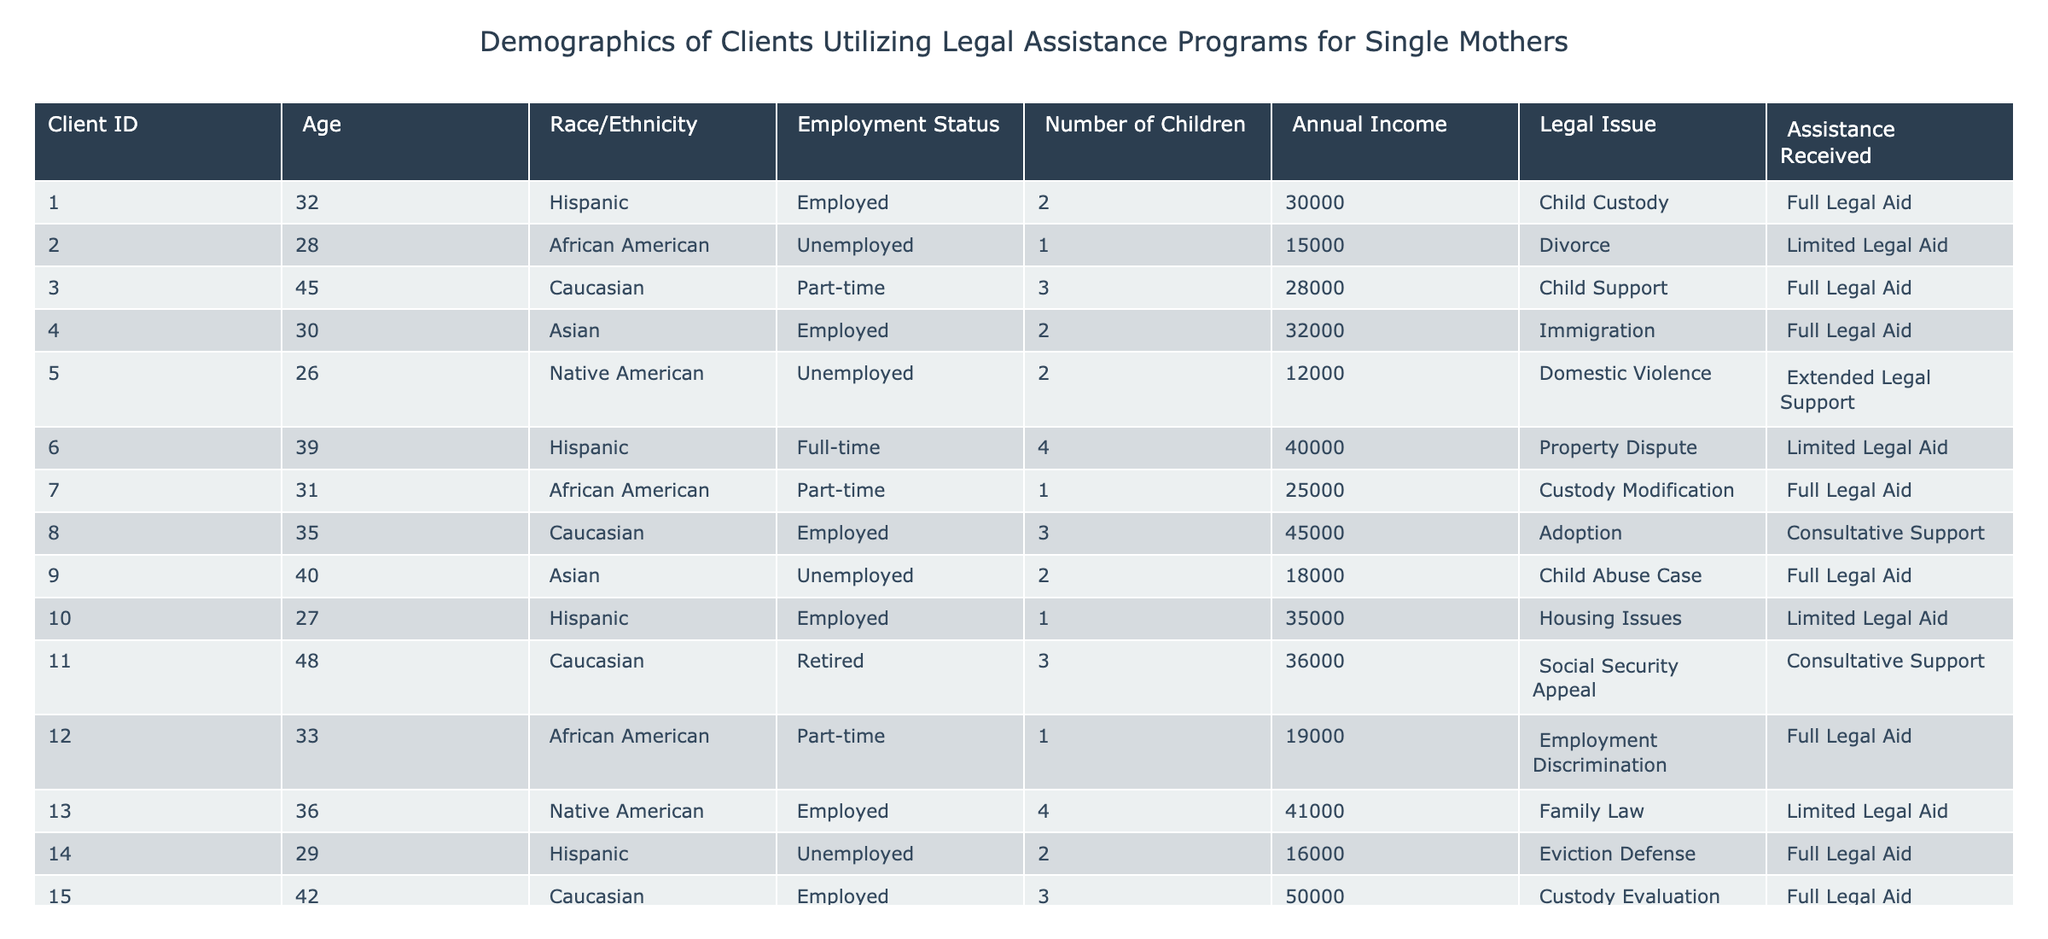What is the most common legal issue for clients in this table? By examining the "Legal Issue" column, we see that "Child Custody" appears 3 times (IDs 1, 7, and 14), which is more than any other legal issue.
Answer: Child Custody How many clients are unemployed? Looking at the "Employment Status" column, we see 5 entries marked as "Unemployed," specifically IDs 2, 5, 6, 9, and 14.
Answer: 5 What is the average number of children for clients receiving full legal aid? There are 8 clients who received full legal aid (IDs 1, 3, 4, 7, 9, 12, 14, 15) with a combined total of children equal to (2 + 3 + 2 + 1 + 2 + 1 + 2 + 3) = 16 children. Dividing by 8 gives us an average of 16/8 = 2.
Answer: 2 Is there a client aged over 40 who received limited legal aid? Checking the "Age" column for clients aged over 40, we see IDs 6 (39) and 11 (48), but amongst these, only ID 6 received limited legal aid. Therefore, there is none.
Answer: No What is the median annual income of clients that are unemployed? The income for unemployed clients (IDs 2, 5, 6, 9, and 14) are 15000, 12000, 40000, 18000, and 16000. Sorting these gives us (12000, 15000, 16000, 18000, 40000). The median is the middle value, so the median is 16000.
Answer: 16000 How many clients employed part-time have a legal issue related to family law? Checking the "Employment Status" and "Legal Issue" columns, we find client IDs 3 (full time) and 12 (part-time) have issues related to family law. Client ID 12 is the only part-time employed client with a family law issue.
Answer: 1 What percentage of clients received extended legal support? There is 1 client (ID 5) who received extended legal support out of a total of 15 clients, leading to a calculation of (1/15)*100 = 6.67%.
Answer: 6.67% Are there any Asian clients with an annual income below $20,000? Reviewing the "Race/Ethnicity" and "Annual Income" columns, we identify ID 9 (Asian) with income of 18000. Therefore, there is one client that meets this criterion.
Answer: Yes Which race/ethnicity group has the highest annual income on average? Looking at the average incomes for each race: Hispanic (30000, 32000, 35000, 16000), African American (15000, 25000, 19000), Caucasian (28000, 45000, 36000, 50000), Asian (32000, 18000), Native American (12000, 41000). The averages are Hispanic 28500, African American 19667, Caucasian 42250, Asian 25000, and Native American 26500. Caucasian has the highest average income.
Answer: Caucasian How many clients have more than 2 children? By checking the "Number of Children" column, clients with more than 2 children are IDs 3, 4, 8, 11, and 15 which totals to 5 clients.
Answer: 5 